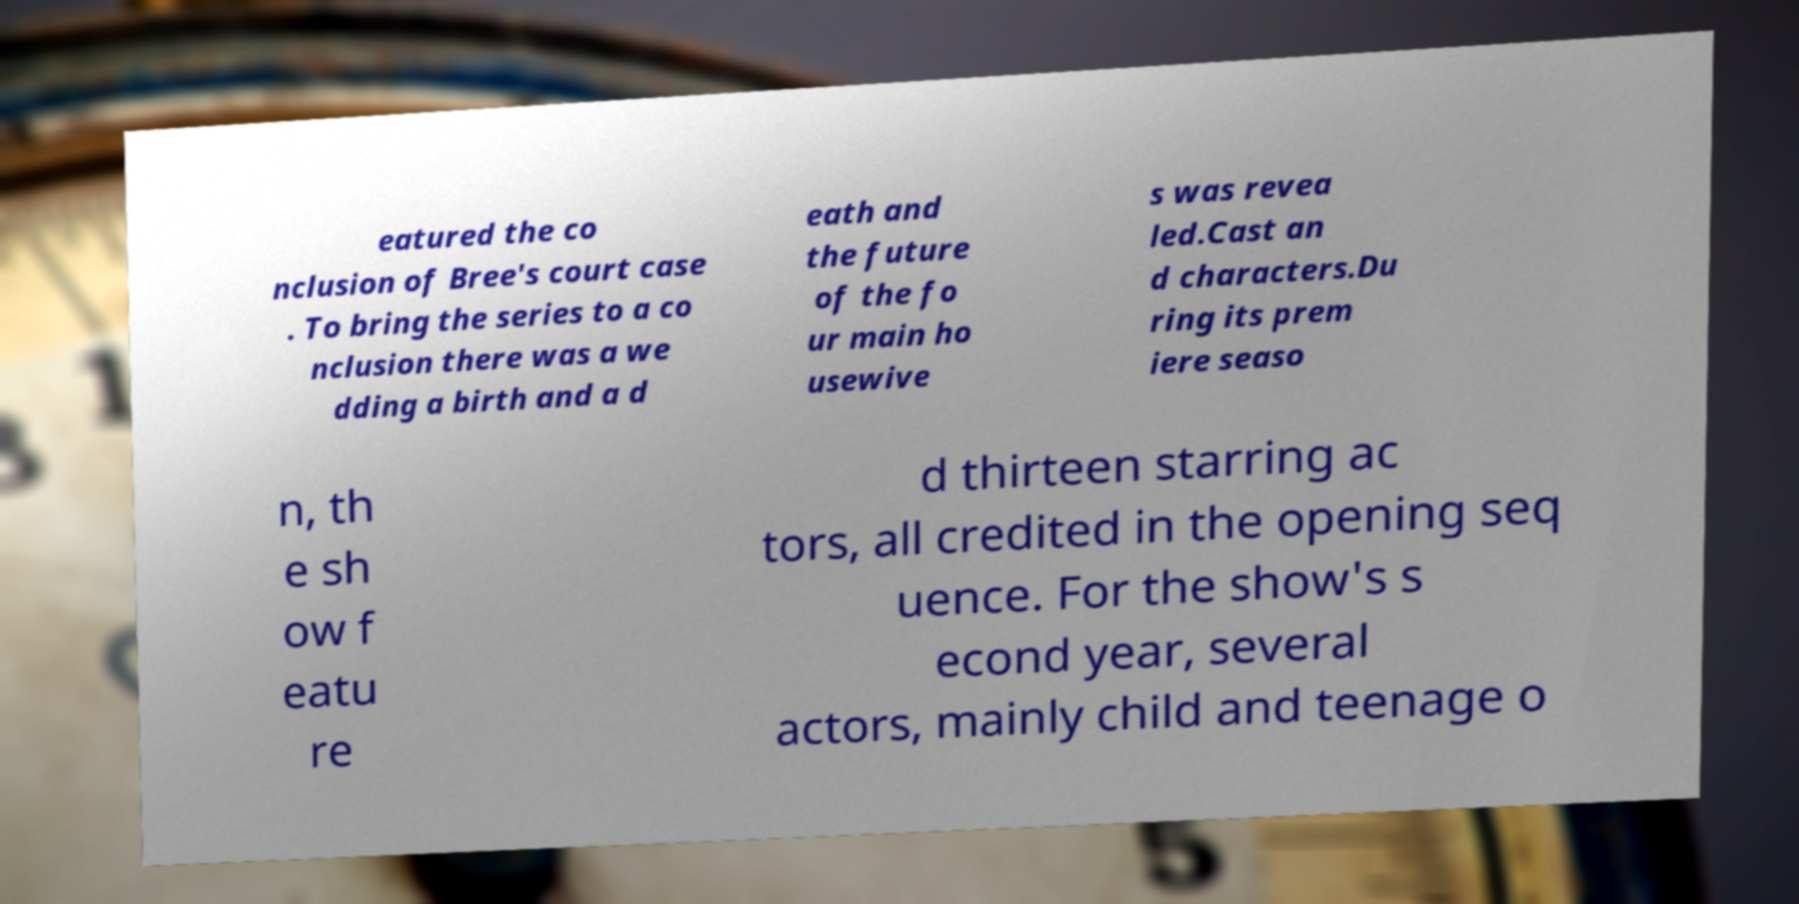For documentation purposes, I need the text within this image transcribed. Could you provide that? eatured the co nclusion of Bree's court case . To bring the series to a co nclusion there was a we dding a birth and a d eath and the future of the fo ur main ho usewive s was revea led.Cast an d characters.Du ring its prem iere seaso n, th e sh ow f eatu re d thirteen starring ac tors, all credited in the opening seq uence. For the show's s econd year, several actors, mainly child and teenage o 